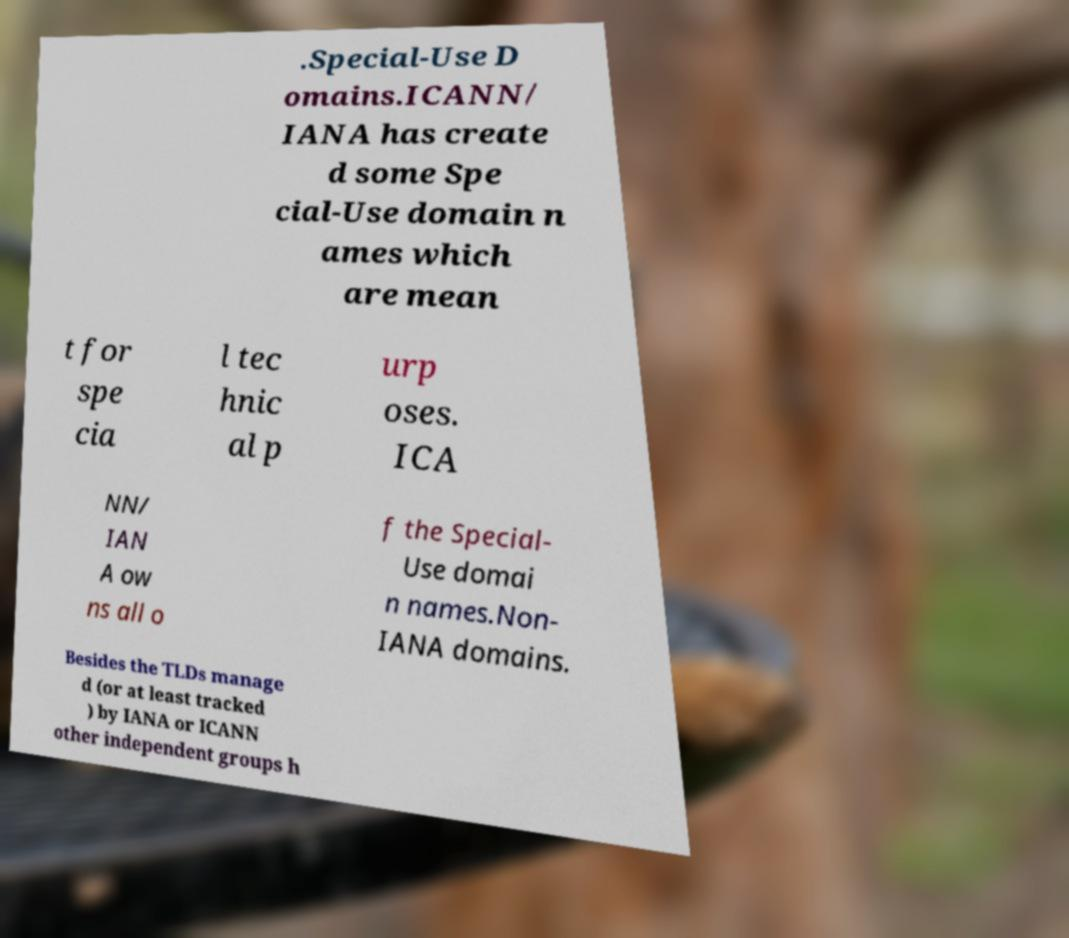Could you extract and type out the text from this image? .Special-Use D omains.ICANN/ IANA has create d some Spe cial-Use domain n ames which are mean t for spe cia l tec hnic al p urp oses. ICA NN/ IAN A ow ns all o f the Special- Use domai n names.Non- IANA domains. Besides the TLDs manage d (or at least tracked ) by IANA or ICANN other independent groups h 